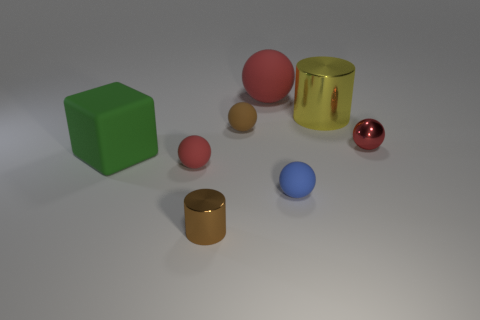How many red balls must be subtracted to get 1 red balls? 2 Subtract all red cylinders. How many red spheres are left? 3 Subtract 1 balls. How many balls are left? 4 Subtract all brown spheres. How many spheres are left? 4 Subtract all metal balls. How many balls are left? 4 Subtract all green balls. Subtract all red cylinders. How many balls are left? 5 Add 1 small brown rubber things. How many objects exist? 9 Subtract all cubes. How many objects are left? 7 Subtract 0 green cylinders. How many objects are left? 8 Subtract all tiny red matte objects. Subtract all tiny red metal things. How many objects are left? 6 